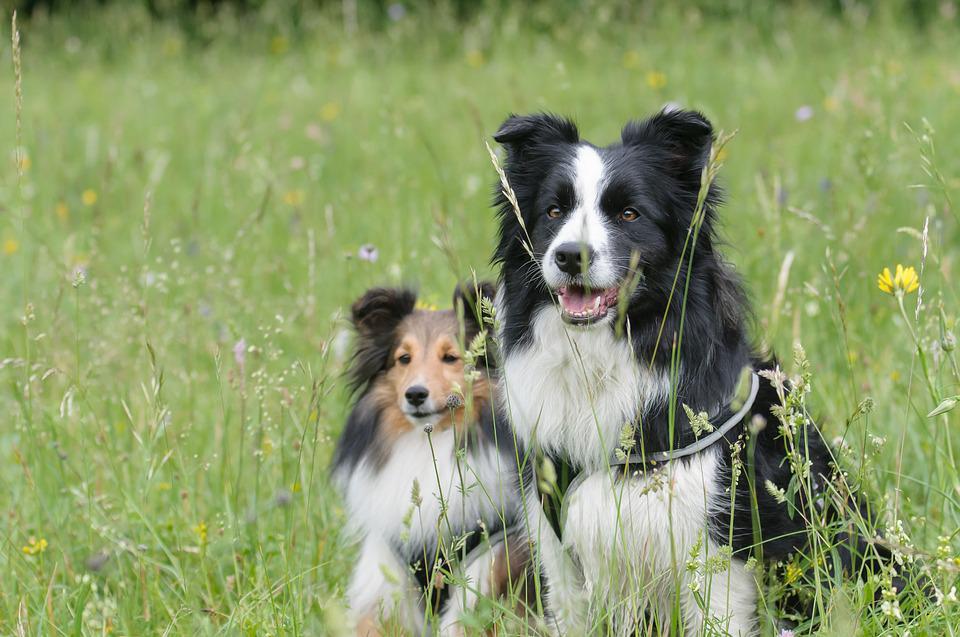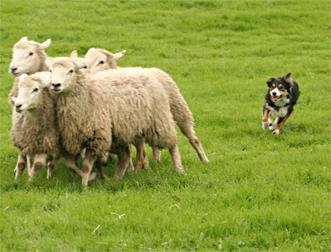The first image is the image on the left, the second image is the image on the right. Considering the images on both sides, is "There are at least two dogs in the image on the left." valid? Answer yes or no. Yes. The first image is the image on the left, the second image is the image on the right. Evaluate the accuracy of this statement regarding the images: "Colored dye is visible on sheep's wool in the right image.". Is it true? Answer yes or no. No. 